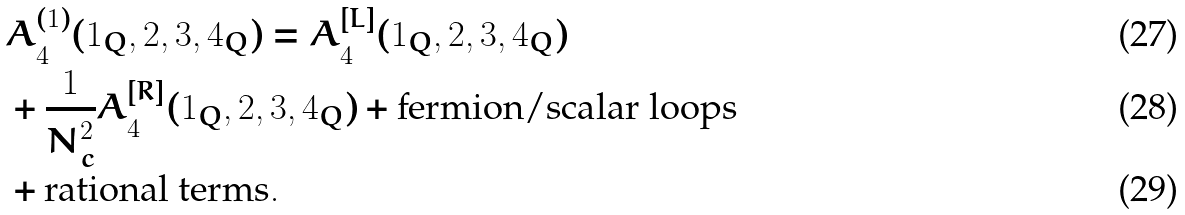Convert formula to latex. <formula><loc_0><loc_0><loc_500><loc_500>& A ^ { ( 1 ) } _ { 4 } ( 1 _ { Q } , 2 , 3 , 4 _ { Q } ) = A ^ { [ L ] } _ { 4 } ( 1 _ { Q } , 2 , 3 , 4 _ { Q } ) \\ & + \frac { 1 } { N _ { c } ^ { 2 } } A ^ { [ R ] } _ { 4 } ( 1 _ { Q } , 2 , 3 , 4 _ { Q } ) + \text {fermion/scalar loops} \\ & + \text {rational terms} .</formula> 